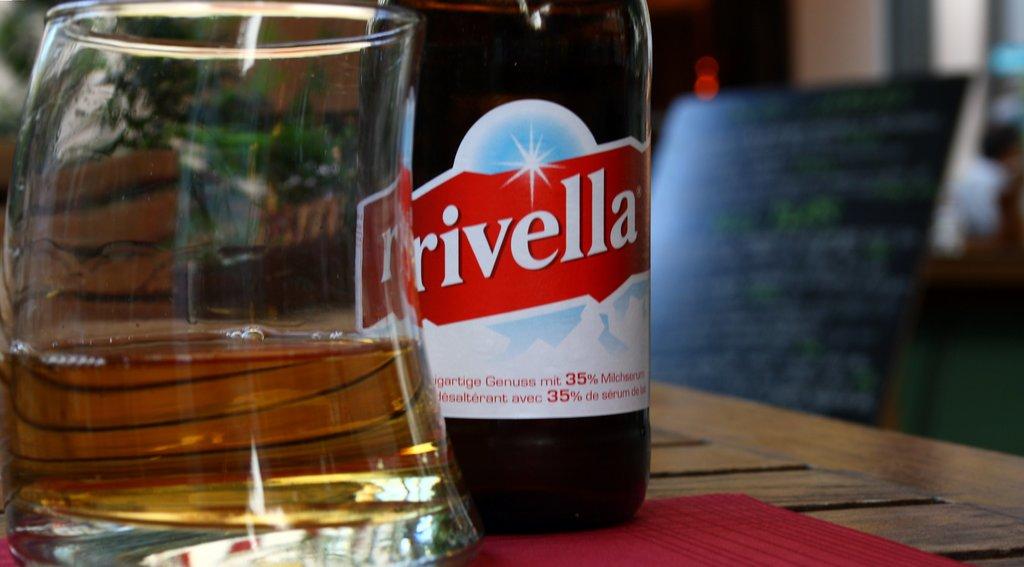What percentage is shown on the alcohol label?
Provide a succinct answer. 35. 